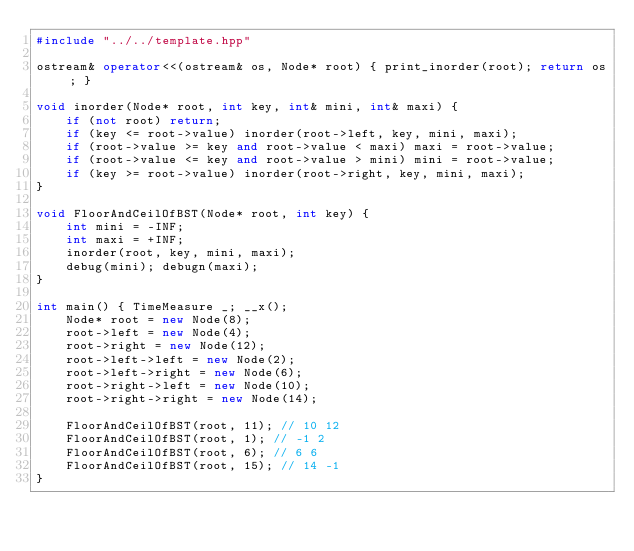<code> <loc_0><loc_0><loc_500><loc_500><_C++_>#include "../../template.hpp"

ostream& operator<<(ostream& os, Node* root) { print_inorder(root); return os; }

void inorder(Node* root, int key, int& mini, int& maxi) {
    if (not root) return;
    if (key <= root->value) inorder(root->left, key, mini, maxi);
    if (root->value >= key and root->value < maxi) maxi = root->value;
    if (root->value <= key and root->value > mini) mini = root->value;
    if (key >= root->value) inorder(root->right, key, mini, maxi);
}

void FloorAndCeilOfBST(Node* root, int key) {
    int mini = -INF;
    int maxi = +INF;
    inorder(root, key, mini, maxi);
    debug(mini); debugn(maxi);
}

int main() { TimeMeasure _; __x();
    Node* root = new Node(8);
    root->left = new Node(4);
    root->right = new Node(12);
    root->left->left = new Node(2);
    root->left->right = new Node(6);
    root->right->left = new Node(10);
    root->right->right = new Node(14);

    FloorAndCeilOfBST(root, 11); // 10 12
    FloorAndCeilOfBST(root, 1); // -1 2
    FloorAndCeilOfBST(root, 6); // 6 6
    FloorAndCeilOfBST(root, 15); // 14 -1
}
</code> 